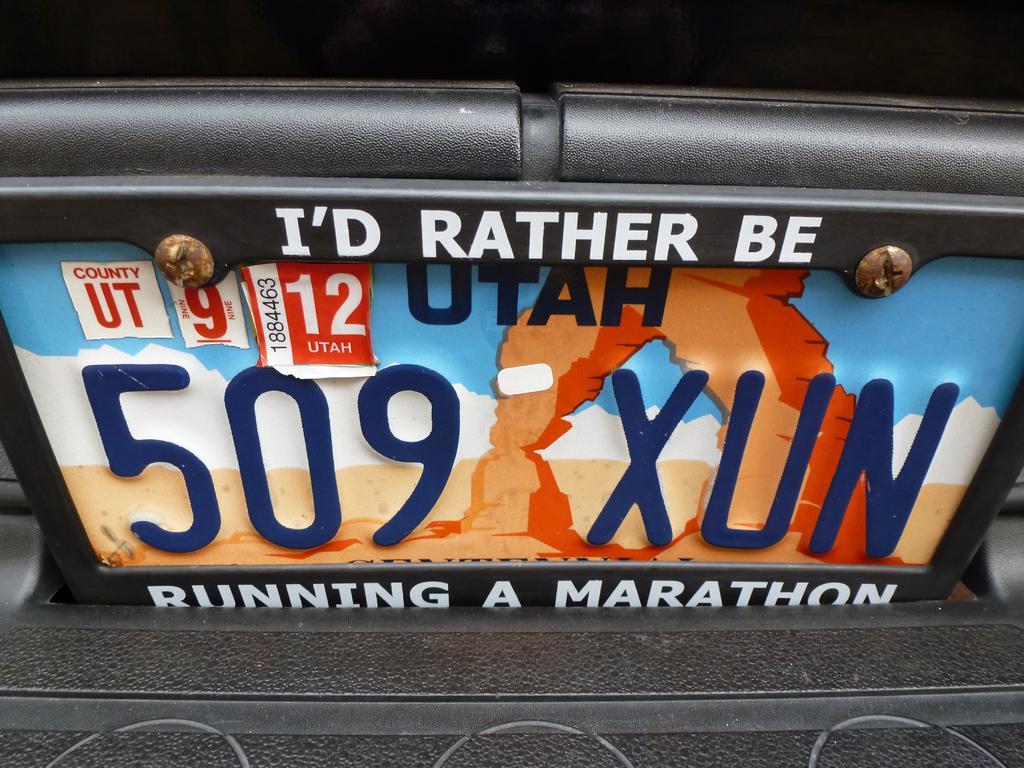<image>
Render a clear and concise summary of the photo. A Utah license plate with 509 XUN on it 